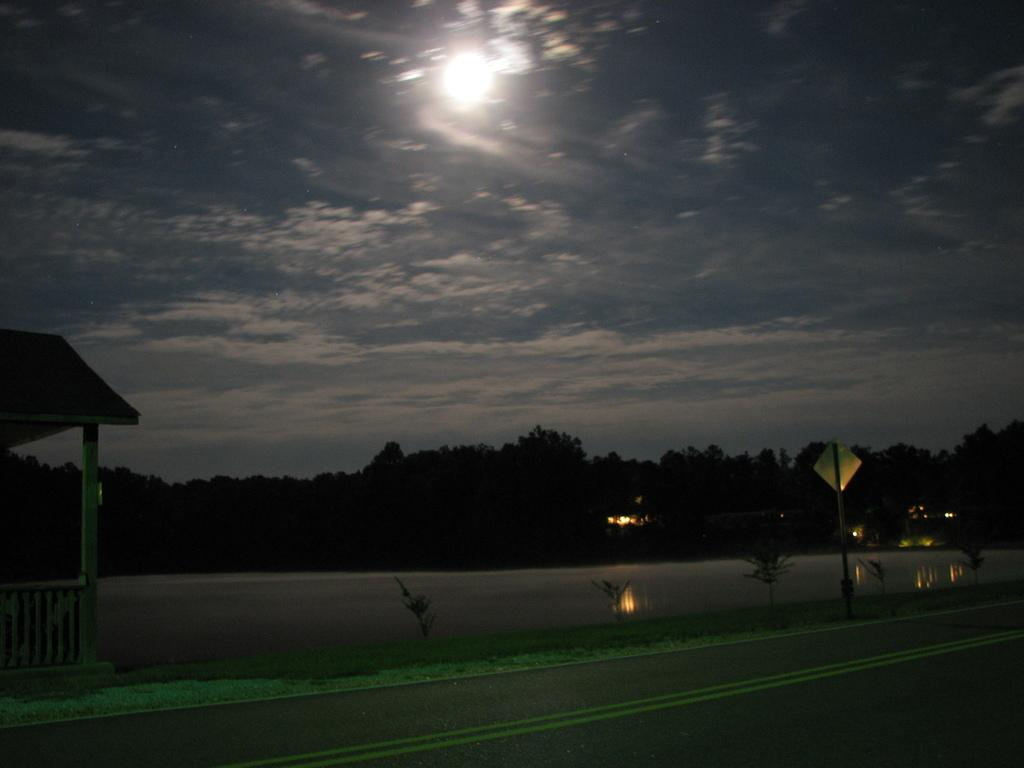What is the main feature of the image? There is a road in the image. What type of vegetation can be seen in the image? There are plants and grass in the image. What structure is present in the image? There is a shed in the image. Can you describe the water visible in the image? There is water visible in the image. What is attached to the pole in the image? There is a board on a pole in the image. What can be seen in the background of the image? There are trees, lights, and the sky visible in the background of the image. What is the condition of the sky in the image? The sky is visible in the background of the image, and there are clouds present. What type of drug is being sold by the authority figure in the image? There is no authority figure or drug present in the image. How can the increase in traffic be observed in the image? The image does not show any traffic or changes in traffic, so it cannot be observed. 